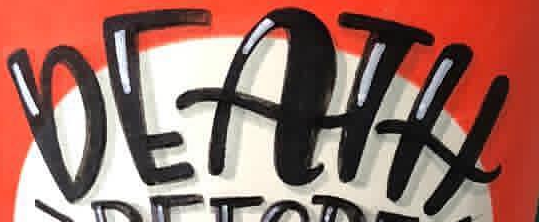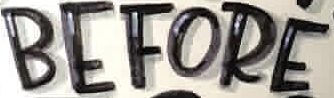What text appears in these images from left to right, separated by a semicolon? DEATH; BEFORE 